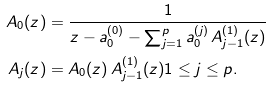Convert formula to latex. <formula><loc_0><loc_0><loc_500><loc_500>A _ { 0 } ( z ) & = \frac { 1 } { z - a _ { 0 } ^ { ( 0 ) } - \sum _ { j = 1 } ^ { p } a _ { 0 } ^ { ( j ) } \, A _ { j - 1 } ^ { ( 1 ) } ( z ) } \\ A _ { j } ( z ) & = A _ { 0 } ( z ) \, A ^ { ( 1 ) } _ { j - 1 } ( z ) 1 \leq j \leq p .</formula> 